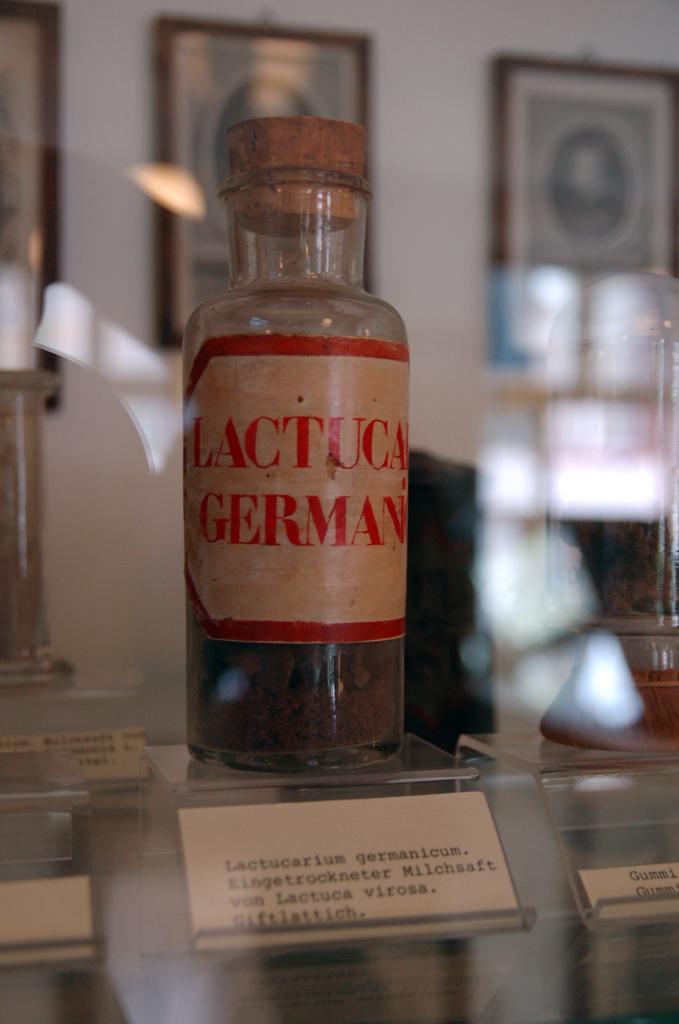Can you describe this image briefly? In the picture in the center we can see the bottle,it was named as "German". And coming to the background there is a wall with photo frames. 